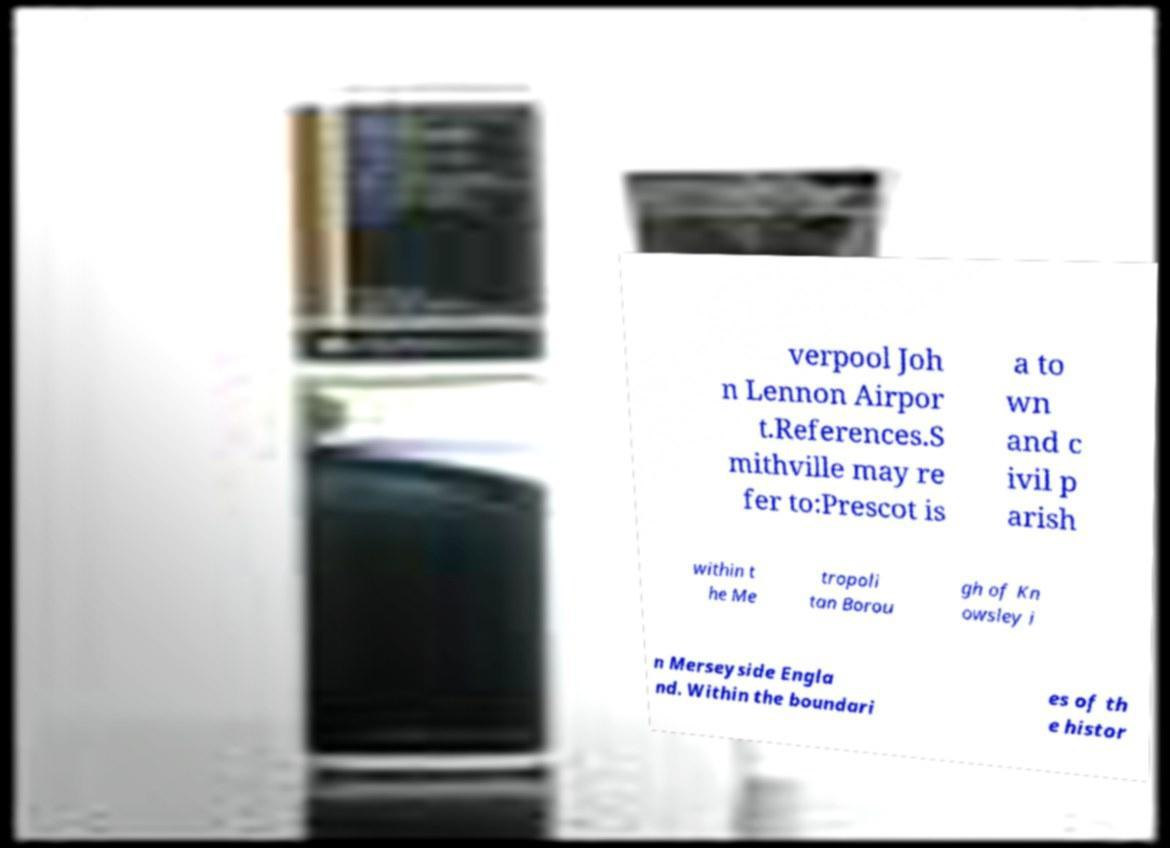Can you accurately transcribe the text from the provided image for me? verpool Joh n Lennon Airpor t.References.S mithville may re fer to:Prescot is a to wn and c ivil p arish within t he Me tropoli tan Borou gh of Kn owsley i n Merseyside Engla nd. Within the boundari es of th e histor 